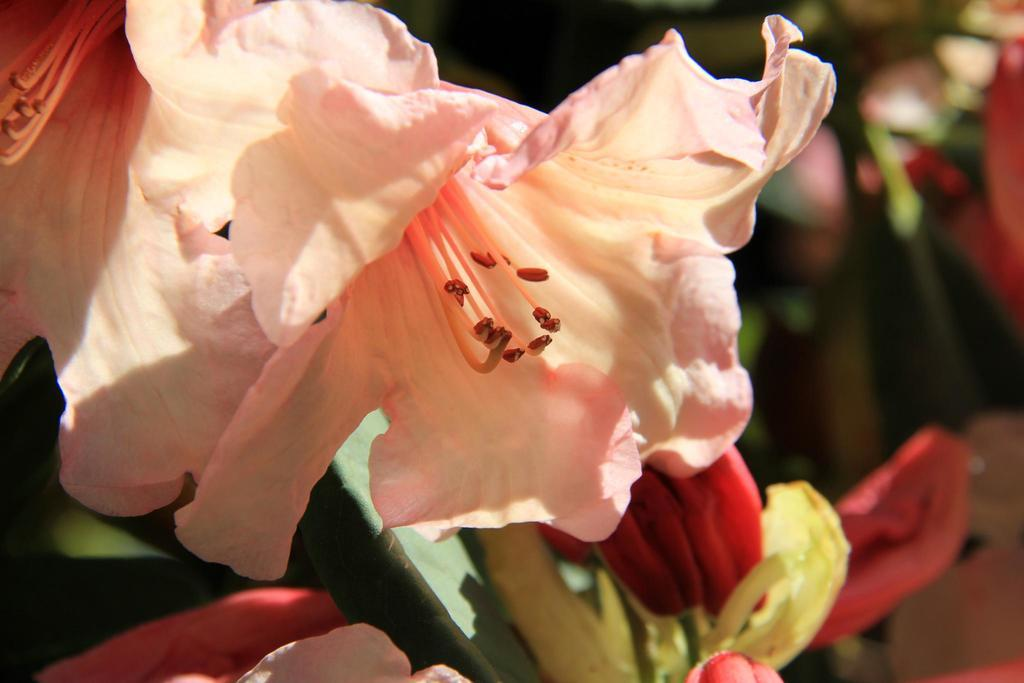What type of plants can be seen in the image? There are flowers in the image. How is the background of the flowers depicted? The background of the flowers is blurred. What type of engine is powering the flowers in the image? There is no engine present in the image, as the subject is flowers. 